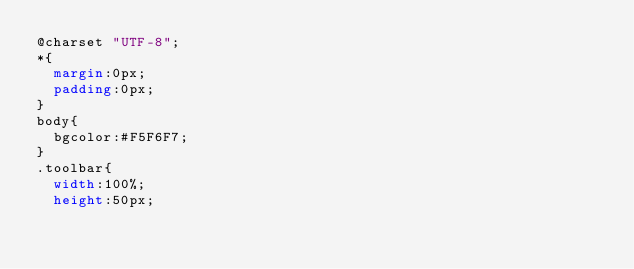Convert code to text. <code><loc_0><loc_0><loc_500><loc_500><_CSS_>@charset "UTF-8";
*{
	margin:0px;
	padding:0px;
}
body{
	bgcolor:#F5F6F7;
}
.toolbar{
	width:100%;
	height:50px;</code> 